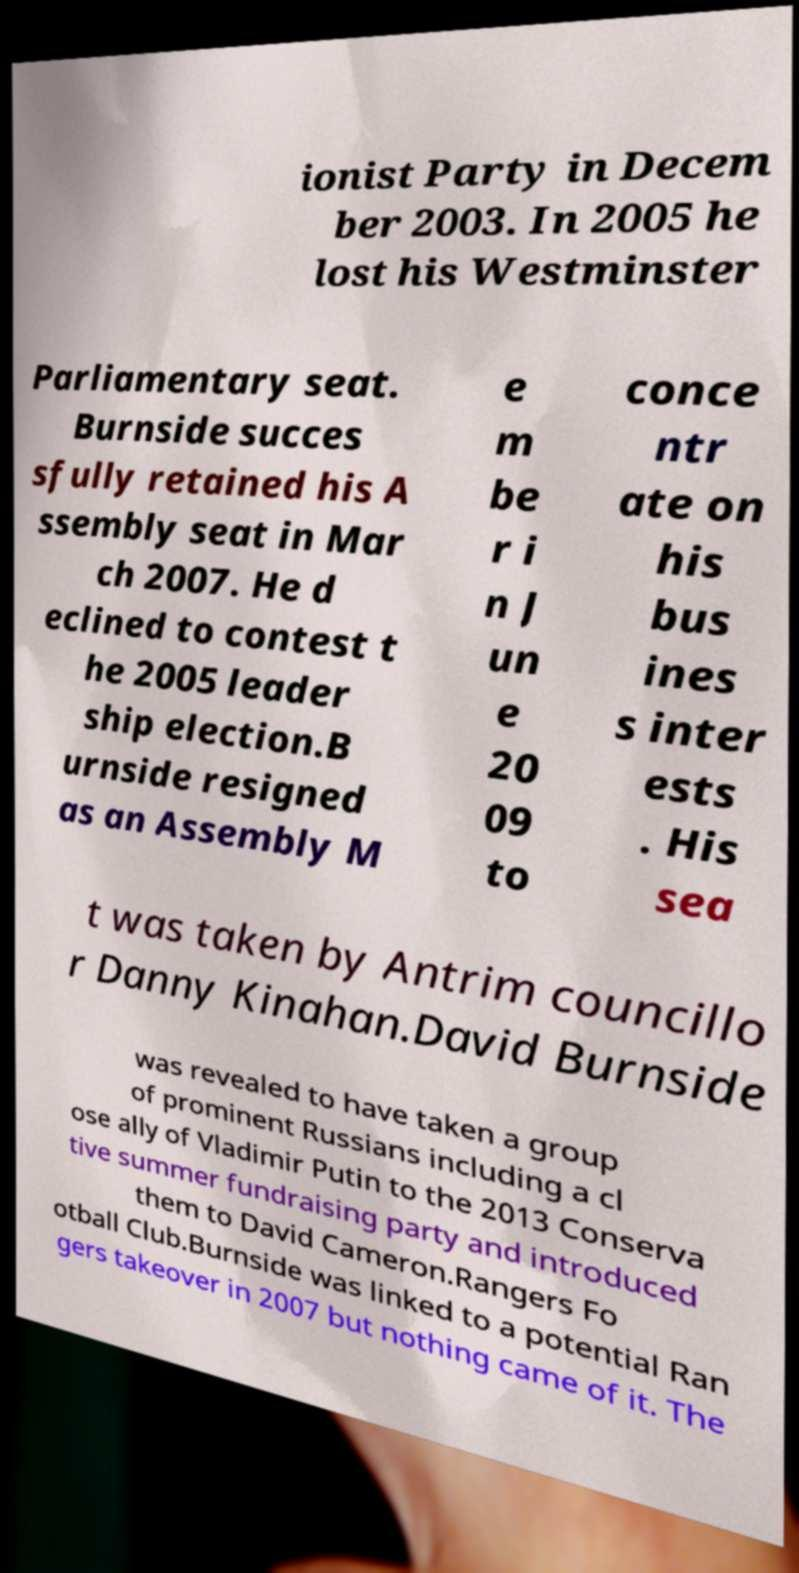Please identify and transcribe the text found in this image. ionist Party in Decem ber 2003. In 2005 he lost his Westminster Parliamentary seat. Burnside succes sfully retained his A ssembly seat in Mar ch 2007. He d eclined to contest t he 2005 leader ship election.B urnside resigned as an Assembly M e m be r i n J un e 20 09 to conce ntr ate on his bus ines s inter ests . His sea t was taken by Antrim councillo r Danny Kinahan.David Burnside was revealed to have taken a group of prominent Russians including a cl ose ally of Vladimir Putin to the 2013 Conserva tive summer fundraising party and introduced them to David Cameron.Rangers Fo otball Club.Burnside was linked to a potential Ran gers takeover in 2007 but nothing came of it. The 